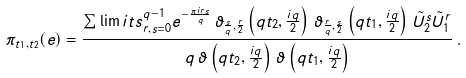Convert formula to latex. <formula><loc_0><loc_0><loc_500><loc_500>\pi _ { t _ { 1 } , t _ { 2 } } ( e ) = \frac { \sum \lim i t s _ { r , s = 0 } ^ { q - 1 } e ^ { - \frac { \pi i r s } { q } } \, \vartheta _ { \frac { s } { q } , \frac { r } { 2 } } \left ( q t _ { 2 } , \frac { i q } { 2 } \right ) \, \vartheta _ { \frac { r } { q } , \frac { s } { 2 } } \left ( q t _ { 1 } , \frac { i q } { 2 } \right ) \, \tilde { U } _ { 2 } ^ { s } \tilde { U } _ { 1 } ^ { r } } { q \, \vartheta \left ( q t _ { 2 } , \frac { i q } { 2 } \right ) \, \vartheta \left ( q t _ { 1 } , \frac { i q } { 2 } \right ) } \, .</formula> 